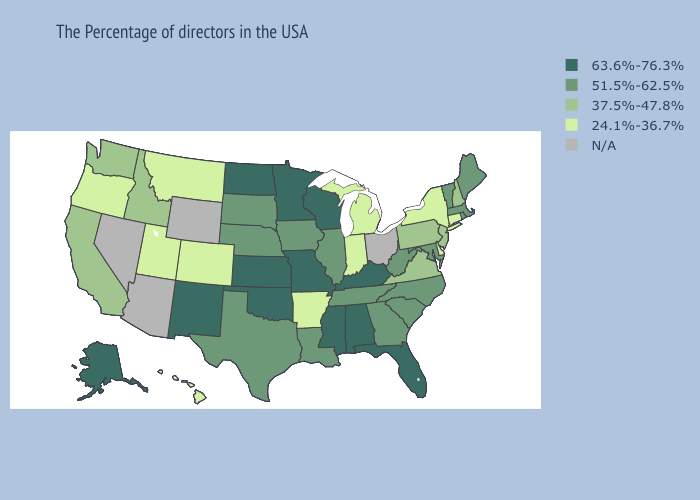Does Virginia have the highest value in the South?
Quick response, please. No. What is the highest value in states that border Utah?
Answer briefly. 63.6%-76.3%. What is the lowest value in states that border Pennsylvania?
Answer briefly. 24.1%-36.7%. What is the value of South Dakota?
Keep it brief. 51.5%-62.5%. Which states have the highest value in the USA?
Be succinct. Florida, Kentucky, Alabama, Wisconsin, Mississippi, Missouri, Minnesota, Kansas, Oklahoma, North Dakota, New Mexico, Alaska. Does the map have missing data?
Quick response, please. Yes. Among the states that border New York , which have the highest value?
Give a very brief answer. Massachusetts, Vermont. What is the value of New York?
Write a very short answer. 24.1%-36.7%. Which states hav the highest value in the West?
Keep it brief. New Mexico, Alaska. What is the lowest value in the USA?
Be succinct. 24.1%-36.7%. What is the value of Idaho?
Quick response, please. 37.5%-47.8%. Among the states that border Missouri , which have the lowest value?
Short answer required. Arkansas. Name the states that have a value in the range 24.1%-36.7%?
Give a very brief answer. Connecticut, New York, Delaware, Michigan, Indiana, Arkansas, Colorado, Utah, Montana, Oregon, Hawaii. What is the highest value in states that border Kansas?
Short answer required. 63.6%-76.3%. 